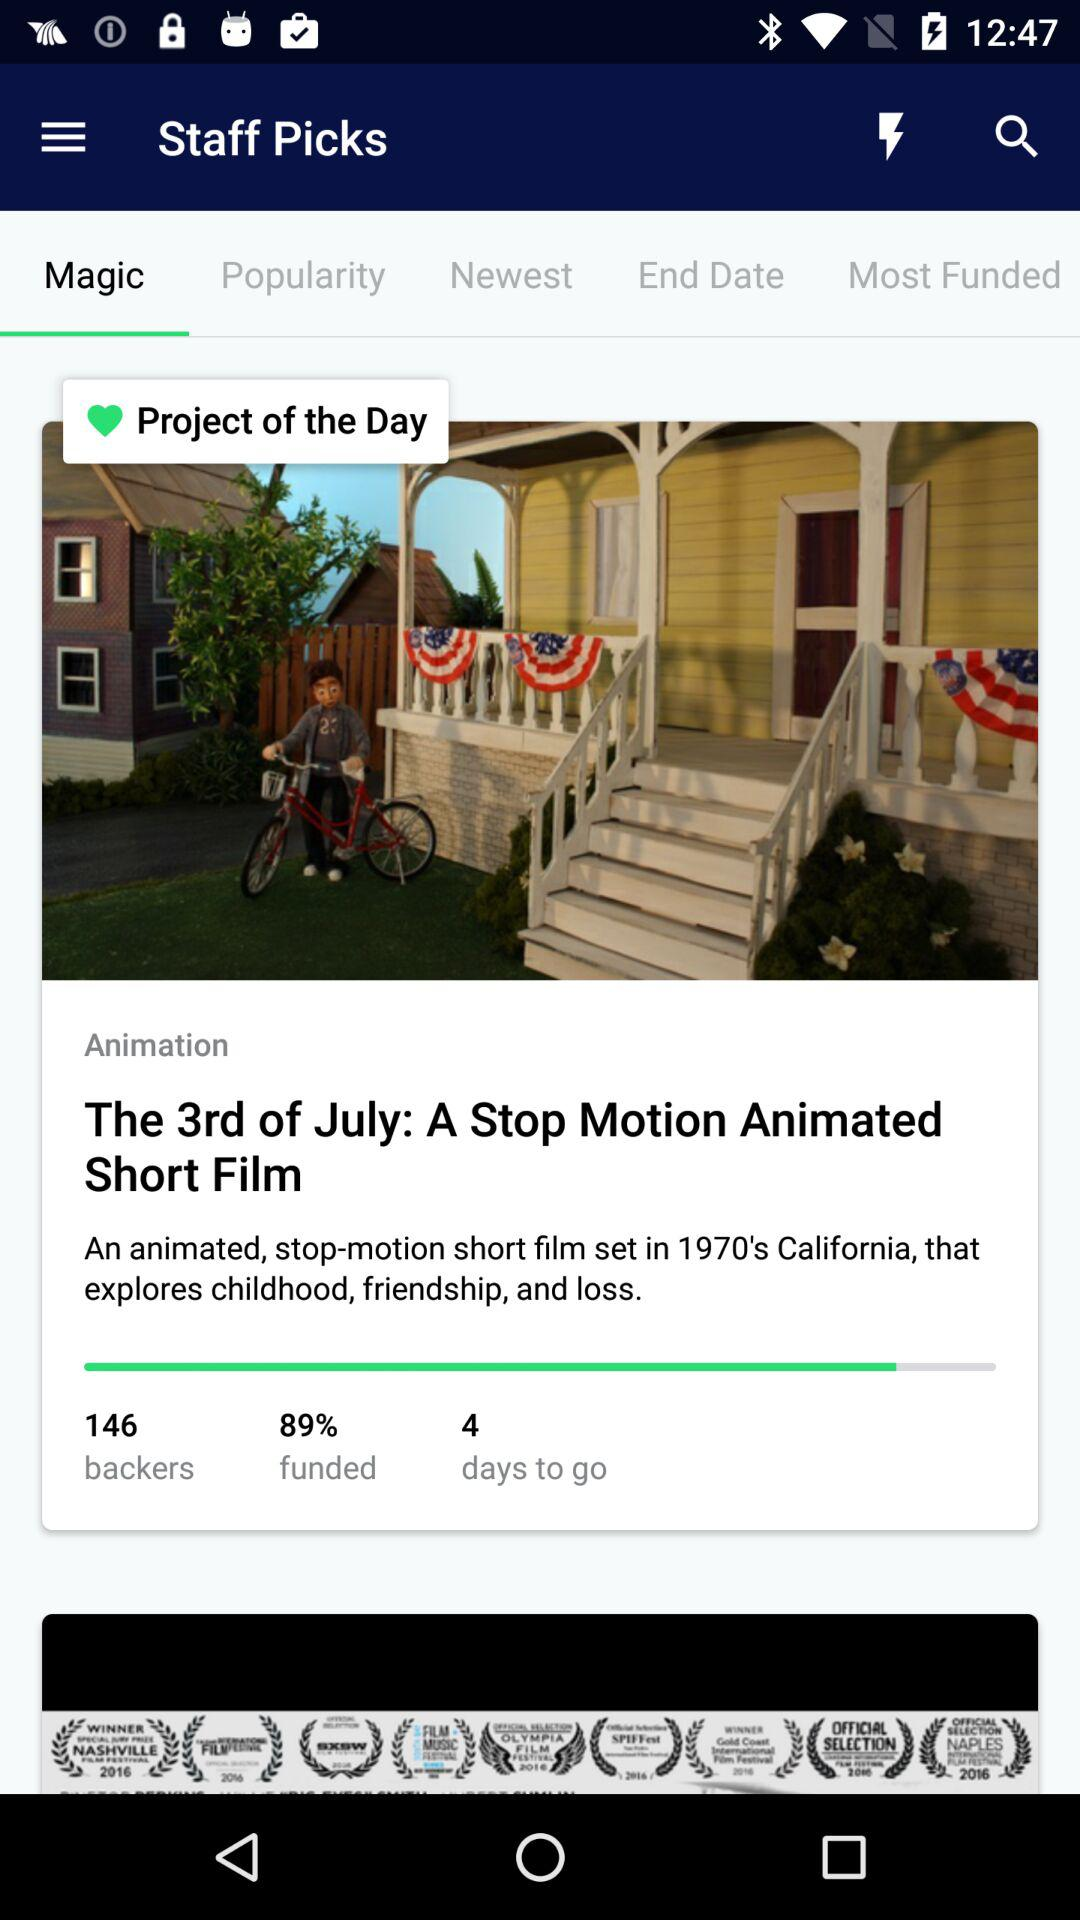How many days to go? There are 4 days to go. 